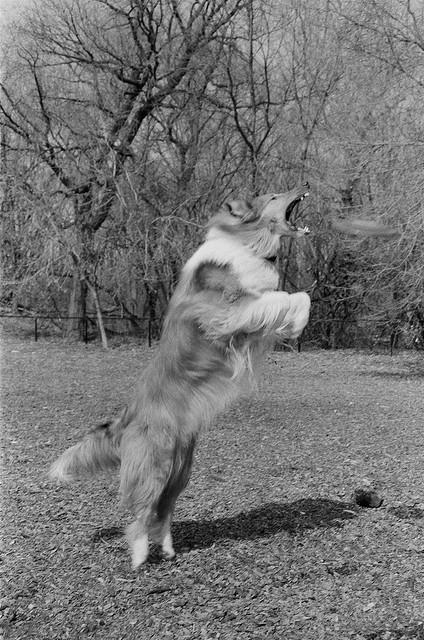Is this pic in black and white?
Short answer required. Yes. What is this dog trying to catch?
Answer briefly. Frisbee. What breed is the dog?
Quick response, please. Collie. 